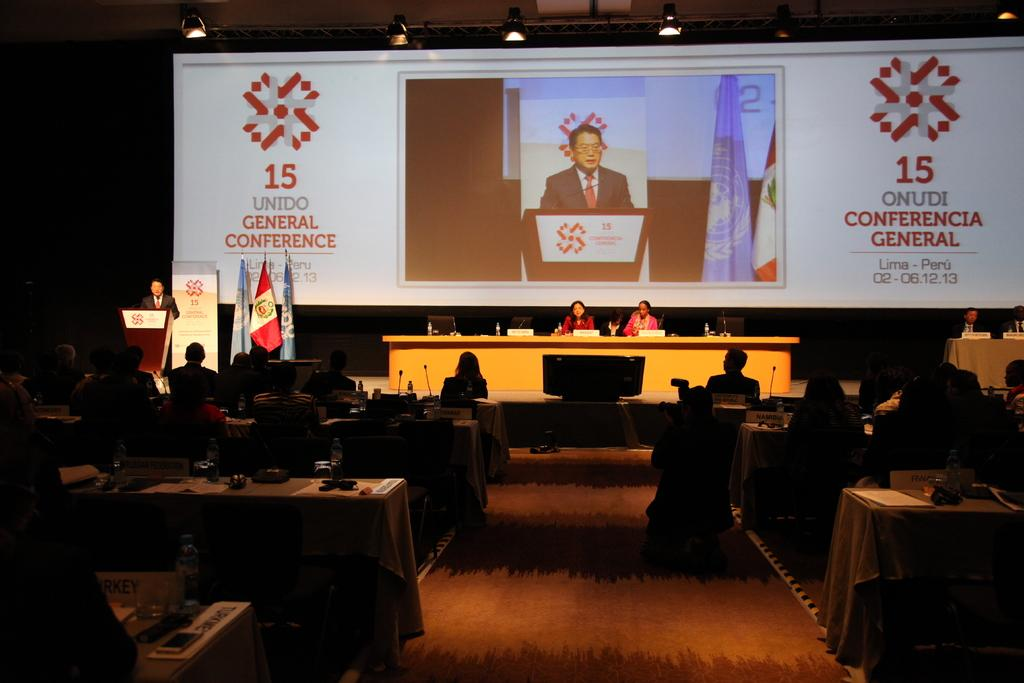What are the people in the image doing? The people in the image are sitting. What object is on the table in the image? There is a microphone on the table. What can be seen in the background of the image? There is a podium, a screen, and a flag in the background. How many wars are depicted in the image? There are no wars depicted in the image; it features people sitting and various objects and elements in the background. What type of cent is used to measure the size of the circle in the image? There is no circle or cent present in the image. 